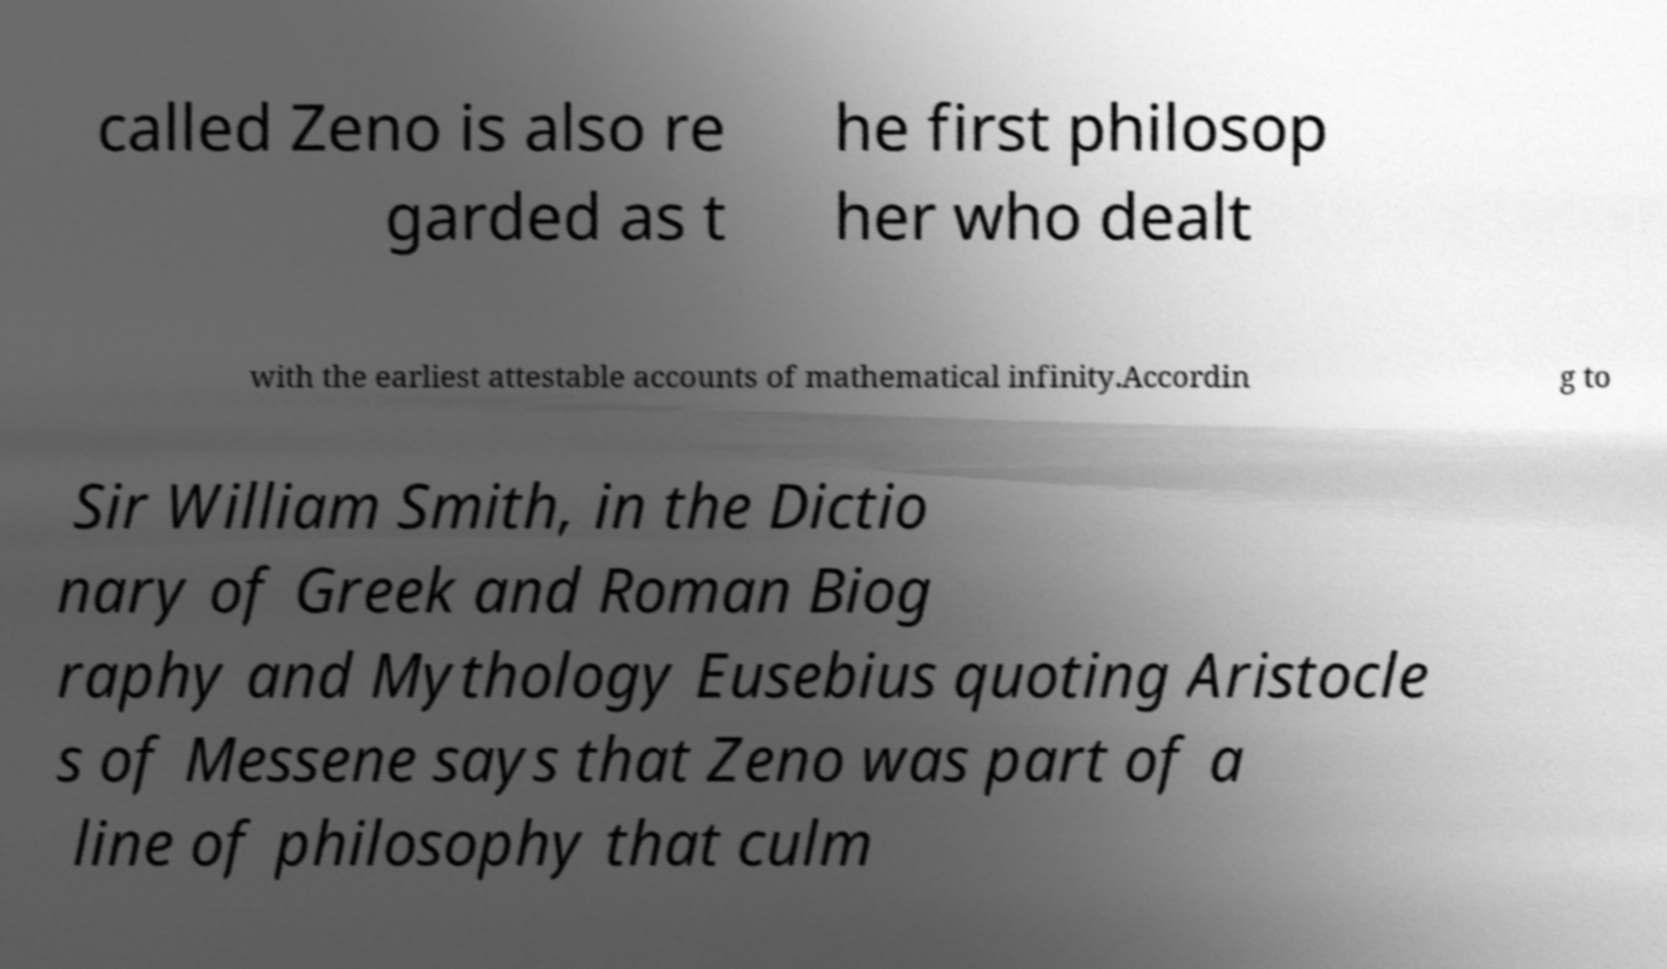Can you read and provide the text displayed in the image?This photo seems to have some interesting text. Can you extract and type it out for me? called Zeno is also re garded as t he first philosop her who dealt with the earliest attestable accounts of mathematical infinity.Accordin g to Sir William Smith, in the Dictio nary of Greek and Roman Biog raphy and Mythology Eusebius quoting Aristocle s of Messene says that Zeno was part of a line of philosophy that culm 